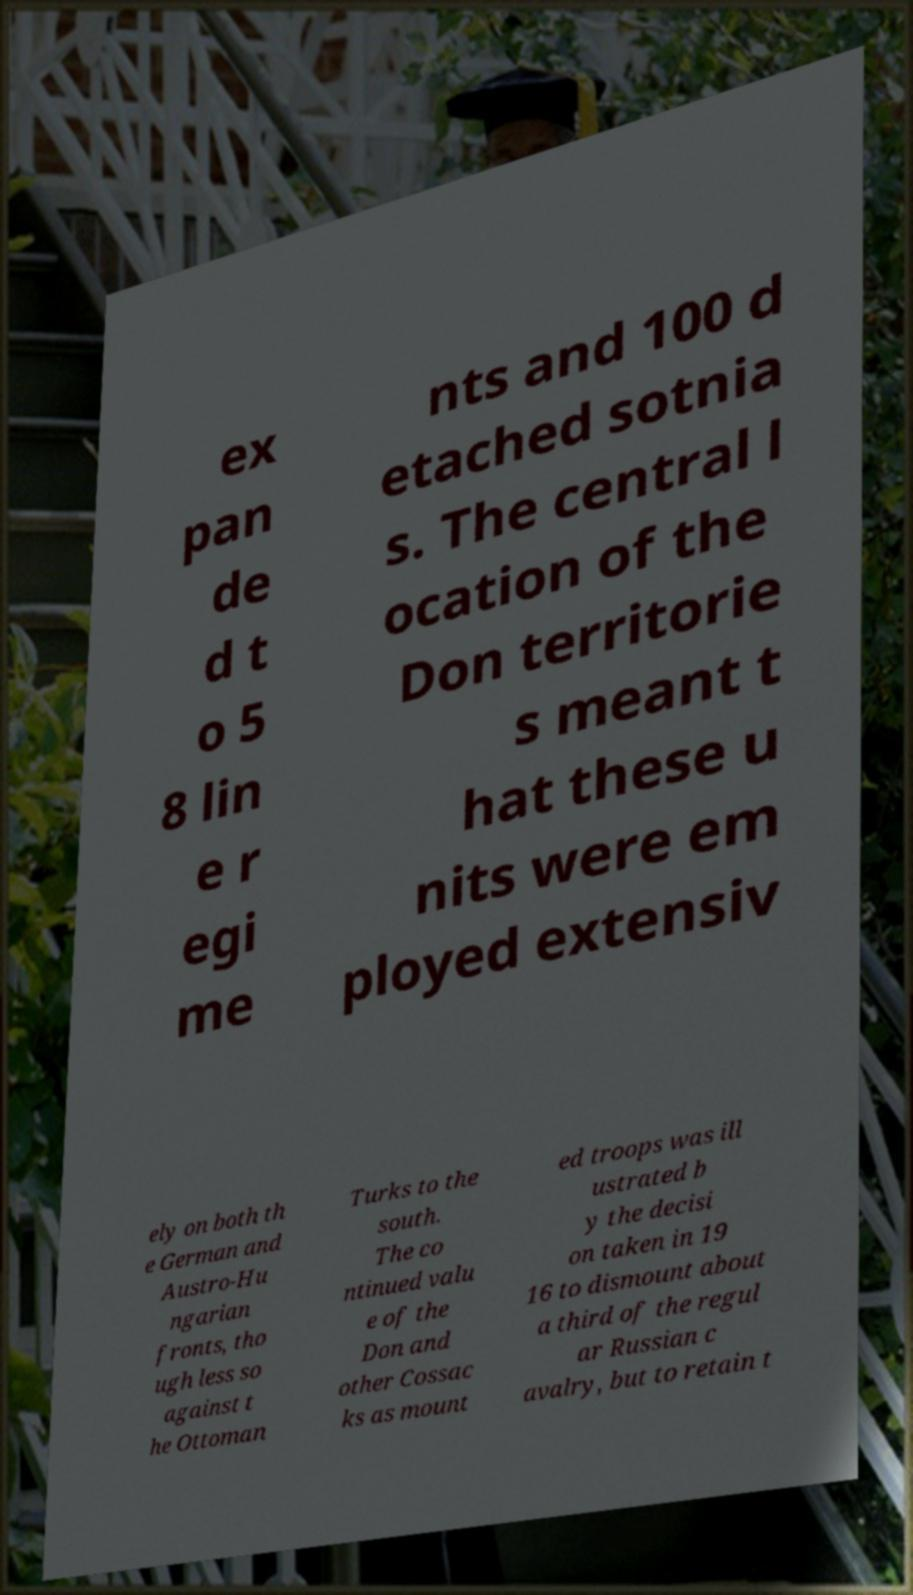Please read and relay the text visible in this image. What does it say? ex pan de d t o 5 8 lin e r egi me nts and 100 d etached sotnia s. The central l ocation of the Don territorie s meant t hat these u nits were em ployed extensiv ely on both th e German and Austro-Hu ngarian fronts, tho ugh less so against t he Ottoman Turks to the south. The co ntinued valu e of the Don and other Cossac ks as mount ed troops was ill ustrated b y the decisi on taken in 19 16 to dismount about a third of the regul ar Russian c avalry, but to retain t 